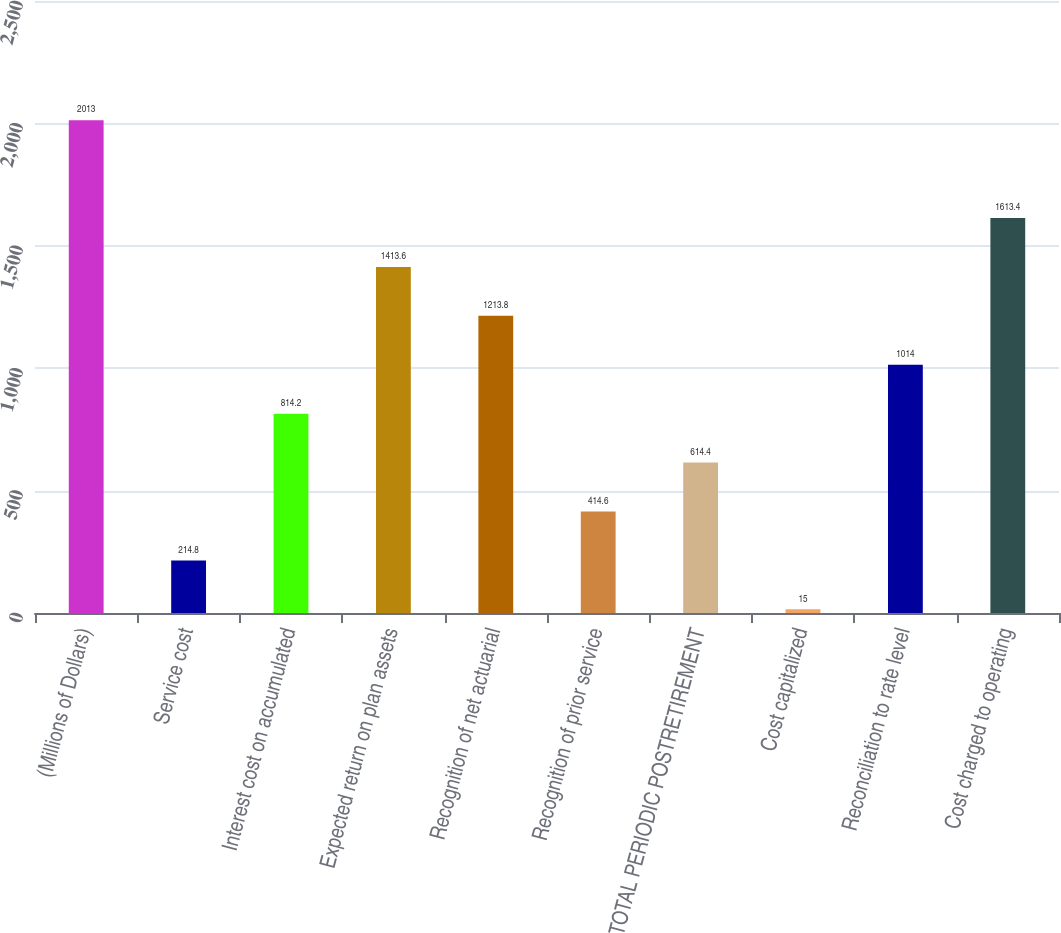Convert chart to OTSL. <chart><loc_0><loc_0><loc_500><loc_500><bar_chart><fcel>(Millions of Dollars)<fcel>Service cost<fcel>Interest cost on accumulated<fcel>Expected return on plan assets<fcel>Recognition of net actuarial<fcel>Recognition of prior service<fcel>TOTAL PERIODIC POSTRETIREMENT<fcel>Cost capitalized<fcel>Reconciliation to rate level<fcel>Cost charged to operating<nl><fcel>2013<fcel>214.8<fcel>814.2<fcel>1413.6<fcel>1213.8<fcel>414.6<fcel>614.4<fcel>15<fcel>1014<fcel>1613.4<nl></chart> 